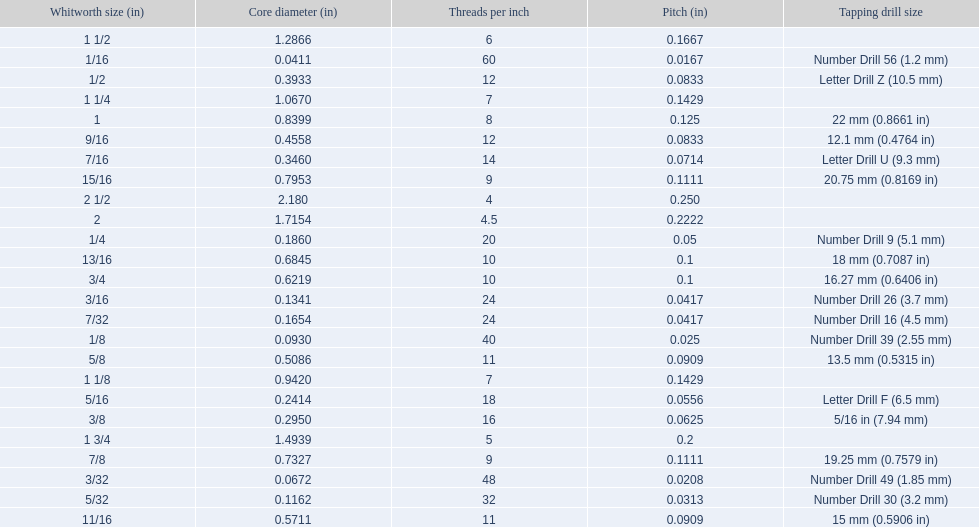What are the sizes of threads per inch? 60, 48, 40, 32, 24, 24, 20, 18, 16, 14, 12, 12, 11, 11, 10, 10, 9, 9, 8, 7, 7, 6, 5, 4.5, 4. Which whitworth size has only 5 threads per inch? 1 3/4. 